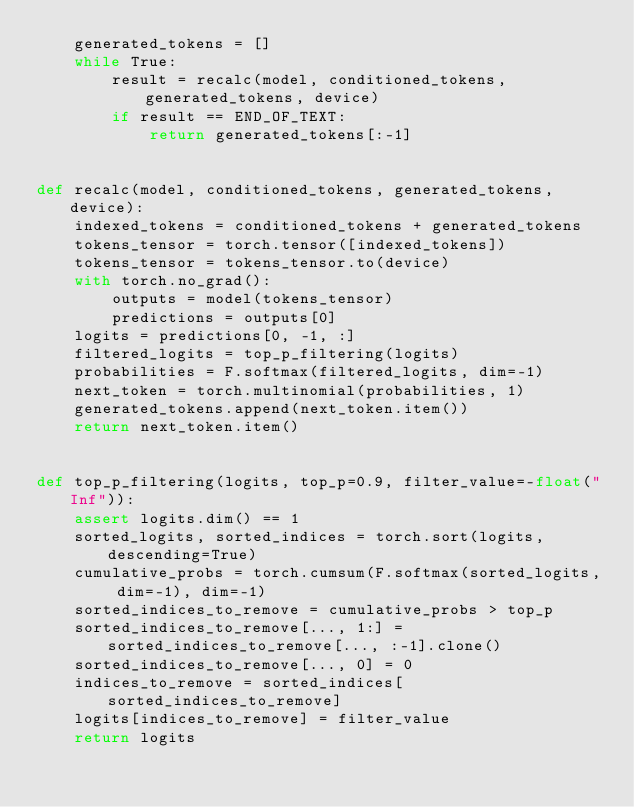Convert code to text. <code><loc_0><loc_0><loc_500><loc_500><_Python_>    generated_tokens = []
    while True:
        result = recalc(model, conditioned_tokens, generated_tokens, device)
        if result == END_OF_TEXT:
            return generated_tokens[:-1]


def recalc(model, conditioned_tokens, generated_tokens, device):
    indexed_tokens = conditioned_tokens + generated_tokens
    tokens_tensor = torch.tensor([indexed_tokens])
    tokens_tensor = tokens_tensor.to(device)
    with torch.no_grad():
        outputs = model(tokens_tensor)
        predictions = outputs[0]
    logits = predictions[0, -1, :]
    filtered_logits = top_p_filtering(logits)
    probabilities = F.softmax(filtered_logits, dim=-1)
    next_token = torch.multinomial(probabilities, 1)
    generated_tokens.append(next_token.item())
    return next_token.item()


def top_p_filtering(logits, top_p=0.9, filter_value=-float("Inf")):
    assert logits.dim() == 1
    sorted_logits, sorted_indices = torch.sort(logits, descending=True)
    cumulative_probs = torch.cumsum(F.softmax(sorted_logits, dim=-1), dim=-1)
    sorted_indices_to_remove = cumulative_probs > top_p
    sorted_indices_to_remove[..., 1:] = sorted_indices_to_remove[..., :-1].clone()
    sorted_indices_to_remove[..., 0] = 0
    indices_to_remove = sorted_indices[sorted_indices_to_remove]
    logits[indices_to_remove] = filter_value
    return logits
</code> 